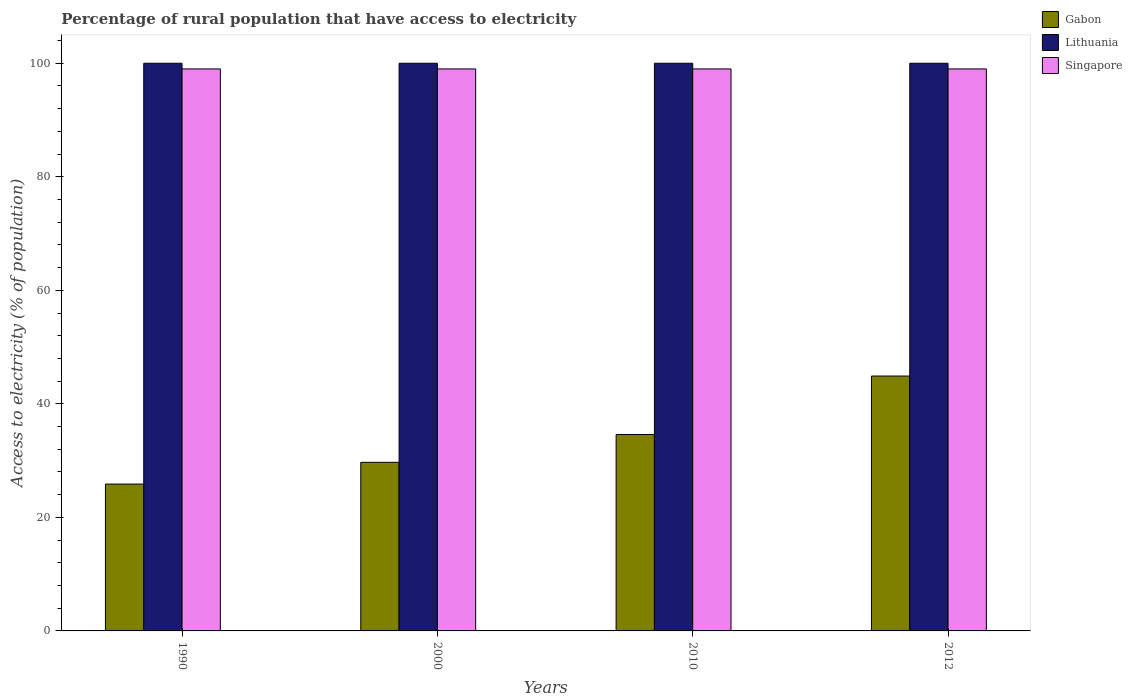Are the number of bars per tick equal to the number of legend labels?
Your answer should be very brief. Yes. How many bars are there on the 3rd tick from the left?
Your response must be concise. 3. What is the label of the 3rd group of bars from the left?
Your response must be concise. 2010. In how many cases, is the number of bars for a given year not equal to the number of legend labels?
Give a very brief answer. 0. What is the percentage of rural population that have access to electricity in Lithuania in 2010?
Offer a very short reply. 100. Across all years, what is the maximum percentage of rural population that have access to electricity in Gabon?
Offer a very short reply. 44.9. Across all years, what is the minimum percentage of rural population that have access to electricity in Gabon?
Offer a terse response. 25.87. In which year was the percentage of rural population that have access to electricity in Lithuania maximum?
Offer a terse response. 1990. What is the total percentage of rural population that have access to electricity in Gabon in the graph?
Provide a succinct answer. 135.07. What is the difference between the percentage of rural population that have access to electricity in Singapore in 1990 and that in 2012?
Provide a succinct answer. 0. What is the difference between the percentage of rural population that have access to electricity in Lithuania in 2000 and the percentage of rural population that have access to electricity in Gabon in 2010?
Provide a succinct answer. 65.4. What is the average percentage of rural population that have access to electricity in Lithuania per year?
Provide a short and direct response. 100. In the year 2000, what is the difference between the percentage of rural population that have access to electricity in Lithuania and percentage of rural population that have access to electricity in Singapore?
Provide a short and direct response. 1. Is the difference between the percentage of rural population that have access to electricity in Lithuania in 2010 and 2012 greater than the difference between the percentage of rural population that have access to electricity in Singapore in 2010 and 2012?
Your answer should be compact. No. What is the difference between the highest and the second highest percentage of rural population that have access to electricity in Lithuania?
Provide a short and direct response. 0. What is the difference between the highest and the lowest percentage of rural population that have access to electricity in Lithuania?
Offer a terse response. 0. In how many years, is the percentage of rural population that have access to electricity in Lithuania greater than the average percentage of rural population that have access to electricity in Lithuania taken over all years?
Your answer should be compact. 0. Is the sum of the percentage of rural population that have access to electricity in Lithuania in 2000 and 2010 greater than the maximum percentage of rural population that have access to electricity in Singapore across all years?
Give a very brief answer. Yes. What does the 3rd bar from the left in 2000 represents?
Offer a very short reply. Singapore. What does the 2nd bar from the right in 2012 represents?
Provide a short and direct response. Lithuania. How many bars are there?
Keep it short and to the point. 12. Are all the bars in the graph horizontal?
Your answer should be compact. No. How many years are there in the graph?
Your answer should be compact. 4. What is the difference between two consecutive major ticks on the Y-axis?
Provide a succinct answer. 20. How many legend labels are there?
Your response must be concise. 3. How are the legend labels stacked?
Offer a very short reply. Vertical. What is the title of the graph?
Offer a very short reply. Percentage of rural population that have access to electricity. Does "Tajikistan" appear as one of the legend labels in the graph?
Offer a very short reply. No. What is the label or title of the X-axis?
Your response must be concise. Years. What is the label or title of the Y-axis?
Provide a short and direct response. Access to electricity (% of population). What is the Access to electricity (% of population) of Gabon in 1990?
Provide a succinct answer. 25.87. What is the Access to electricity (% of population) of Lithuania in 1990?
Offer a terse response. 100. What is the Access to electricity (% of population) of Gabon in 2000?
Offer a very short reply. 29.7. What is the Access to electricity (% of population) in Lithuania in 2000?
Offer a very short reply. 100. What is the Access to electricity (% of population) in Singapore in 2000?
Make the answer very short. 99. What is the Access to electricity (% of population) of Gabon in 2010?
Your response must be concise. 34.6. What is the Access to electricity (% of population) in Lithuania in 2010?
Provide a succinct answer. 100. What is the Access to electricity (% of population) in Gabon in 2012?
Keep it short and to the point. 44.9. What is the Access to electricity (% of population) of Lithuania in 2012?
Make the answer very short. 100. Across all years, what is the maximum Access to electricity (% of population) of Gabon?
Offer a terse response. 44.9. Across all years, what is the maximum Access to electricity (% of population) in Lithuania?
Your answer should be compact. 100. Across all years, what is the minimum Access to electricity (% of population) of Gabon?
Give a very brief answer. 25.87. What is the total Access to electricity (% of population) in Gabon in the graph?
Offer a terse response. 135.07. What is the total Access to electricity (% of population) of Lithuania in the graph?
Keep it short and to the point. 400. What is the total Access to electricity (% of population) of Singapore in the graph?
Give a very brief answer. 396. What is the difference between the Access to electricity (% of population) of Gabon in 1990 and that in 2000?
Keep it short and to the point. -3.83. What is the difference between the Access to electricity (% of population) in Gabon in 1990 and that in 2010?
Offer a very short reply. -8.73. What is the difference between the Access to electricity (% of population) of Lithuania in 1990 and that in 2010?
Your answer should be very brief. 0. What is the difference between the Access to electricity (% of population) of Gabon in 1990 and that in 2012?
Ensure brevity in your answer.  -19.03. What is the difference between the Access to electricity (% of population) in Lithuania in 1990 and that in 2012?
Your answer should be compact. 0. What is the difference between the Access to electricity (% of population) in Singapore in 1990 and that in 2012?
Your answer should be very brief. 0. What is the difference between the Access to electricity (% of population) of Singapore in 2000 and that in 2010?
Your response must be concise. 0. What is the difference between the Access to electricity (% of population) in Gabon in 2000 and that in 2012?
Provide a short and direct response. -15.2. What is the difference between the Access to electricity (% of population) of Gabon in 2010 and that in 2012?
Give a very brief answer. -10.3. What is the difference between the Access to electricity (% of population) of Gabon in 1990 and the Access to electricity (% of population) of Lithuania in 2000?
Offer a very short reply. -74.13. What is the difference between the Access to electricity (% of population) in Gabon in 1990 and the Access to electricity (% of population) in Singapore in 2000?
Keep it short and to the point. -73.13. What is the difference between the Access to electricity (% of population) in Lithuania in 1990 and the Access to electricity (% of population) in Singapore in 2000?
Provide a short and direct response. 1. What is the difference between the Access to electricity (% of population) in Gabon in 1990 and the Access to electricity (% of population) in Lithuania in 2010?
Ensure brevity in your answer.  -74.13. What is the difference between the Access to electricity (% of population) of Gabon in 1990 and the Access to electricity (% of population) of Singapore in 2010?
Your answer should be compact. -73.13. What is the difference between the Access to electricity (% of population) in Gabon in 1990 and the Access to electricity (% of population) in Lithuania in 2012?
Provide a succinct answer. -74.13. What is the difference between the Access to electricity (% of population) in Gabon in 1990 and the Access to electricity (% of population) in Singapore in 2012?
Ensure brevity in your answer.  -73.13. What is the difference between the Access to electricity (% of population) of Lithuania in 1990 and the Access to electricity (% of population) of Singapore in 2012?
Provide a short and direct response. 1. What is the difference between the Access to electricity (% of population) of Gabon in 2000 and the Access to electricity (% of population) of Lithuania in 2010?
Offer a very short reply. -70.3. What is the difference between the Access to electricity (% of population) in Gabon in 2000 and the Access to electricity (% of population) in Singapore in 2010?
Your response must be concise. -69.3. What is the difference between the Access to electricity (% of population) in Lithuania in 2000 and the Access to electricity (% of population) in Singapore in 2010?
Your response must be concise. 1. What is the difference between the Access to electricity (% of population) in Gabon in 2000 and the Access to electricity (% of population) in Lithuania in 2012?
Offer a very short reply. -70.3. What is the difference between the Access to electricity (% of population) of Gabon in 2000 and the Access to electricity (% of population) of Singapore in 2012?
Ensure brevity in your answer.  -69.3. What is the difference between the Access to electricity (% of population) in Lithuania in 2000 and the Access to electricity (% of population) in Singapore in 2012?
Give a very brief answer. 1. What is the difference between the Access to electricity (% of population) in Gabon in 2010 and the Access to electricity (% of population) in Lithuania in 2012?
Your answer should be compact. -65.4. What is the difference between the Access to electricity (% of population) of Gabon in 2010 and the Access to electricity (% of population) of Singapore in 2012?
Give a very brief answer. -64.4. What is the difference between the Access to electricity (% of population) of Lithuania in 2010 and the Access to electricity (% of population) of Singapore in 2012?
Offer a terse response. 1. What is the average Access to electricity (% of population) of Gabon per year?
Make the answer very short. 33.77. In the year 1990, what is the difference between the Access to electricity (% of population) in Gabon and Access to electricity (% of population) in Lithuania?
Give a very brief answer. -74.13. In the year 1990, what is the difference between the Access to electricity (% of population) in Gabon and Access to electricity (% of population) in Singapore?
Offer a terse response. -73.13. In the year 2000, what is the difference between the Access to electricity (% of population) in Gabon and Access to electricity (% of population) in Lithuania?
Provide a succinct answer. -70.3. In the year 2000, what is the difference between the Access to electricity (% of population) in Gabon and Access to electricity (% of population) in Singapore?
Give a very brief answer. -69.3. In the year 2010, what is the difference between the Access to electricity (% of population) of Gabon and Access to electricity (% of population) of Lithuania?
Keep it short and to the point. -65.4. In the year 2010, what is the difference between the Access to electricity (% of population) of Gabon and Access to electricity (% of population) of Singapore?
Make the answer very short. -64.4. In the year 2010, what is the difference between the Access to electricity (% of population) of Lithuania and Access to electricity (% of population) of Singapore?
Provide a short and direct response. 1. In the year 2012, what is the difference between the Access to electricity (% of population) in Gabon and Access to electricity (% of population) in Lithuania?
Make the answer very short. -55.1. In the year 2012, what is the difference between the Access to electricity (% of population) of Gabon and Access to electricity (% of population) of Singapore?
Keep it short and to the point. -54.1. What is the ratio of the Access to electricity (% of population) in Gabon in 1990 to that in 2000?
Offer a very short reply. 0.87. What is the ratio of the Access to electricity (% of population) in Lithuania in 1990 to that in 2000?
Keep it short and to the point. 1. What is the ratio of the Access to electricity (% of population) in Gabon in 1990 to that in 2010?
Provide a short and direct response. 0.75. What is the ratio of the Access to electricity (% of population) of Gabon in 1990 to that in 2012?
Your answer should be very brief. 0.58. What is the ratio of the Access to electricity (% of population) of Lithuania in 1990 to that in 2012?
Provide a short and direct response. 1. What is the ratio of the Access to electricity (% of population) of Singapore in 1990 to that in 2012?
Offer a very short reply. 1. What is the ratio of the Access to electricity (% of population) in Gabon in 2000 to that in 2010?
Offer a terse response. 0.86. What is the ratio of the Access to electricity (% of population) in Singapore in 2000 to that in 2010?
Provide a succinct answer. 1. What is the ratio of the Access to electricity (% of population) of Gabon in 2000 to that in 2012?
Give a very brief answer. 0.66. What is the ratio of the Access to electricity (% of population) of Singapore in 2000 to that in 2012?
Your response must be concise. 1. What is the ratio of the Access to electricity (% of population) of Gabon in 2010 to that in 2012?
Offer a terse response. 0.77. What is the difference between the highest and the second highest Access to electricity (% of population) of Lithuania?
Provide a short and direct response. 0. What is the difference between the highest and the second highest Access to electricity (% of population) of Singapore?
Provide a short and direct response. 0. What is the difference between the highest and the lowest Access to electricity (% of population) of Gabon?
Ensure brevity in your answer.  19.03. 